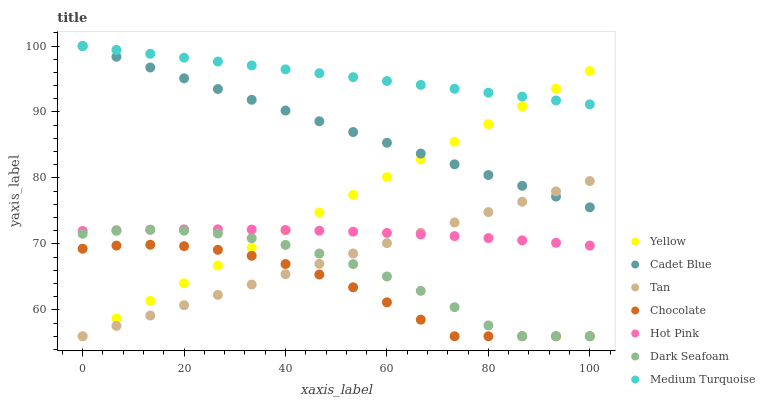Does Chocolate have the minimum area under the curve?
Answer yes or no. Yes. Does Medium Turquoise have the maximum area under the curve?
Answer yes or no. Yes. Does Hot Pink have the minimum area under the curve?
Answer yes or no. No. Does Hot Pink have the maximum area under the curve?
Answer yes or no. No. Is Medium Turquoise the smoothest?
Answer yes or no. Yes. Is Dark Seafoam the roughest?
Answer yes or no. Yes. Is Hot Pink the smoothest?
Answer yes or no. No. Is Hot Pink the roughest?
Answer yes or no. No. Does Yellow have the lowest value?
Answer yes or no. Yes. Does Hot Pink have the lowest value?
Answer yes or no. No. Does Medium Turquoise have the highest value?
Answer yes or no. Yes. Does Hot Pink have the highest value?
Answer yes or no. No. Is Hot Pink less than Cadet Blue?
Answer yes or no. Yes. Is Cadet Blue greater than Chocolate?
Answer yes or no. Yes. Does Dark Seafoam intersect Tan?
Answer yes or no. Yes. Is Dark Seafoam less than Tan?
Answer yes or no. No. Is Dark Seafoam greater than Tan?
Answer yes or no. No. Does Hot Pink intersect Cadet Blue?
Answer yes or no. No. 